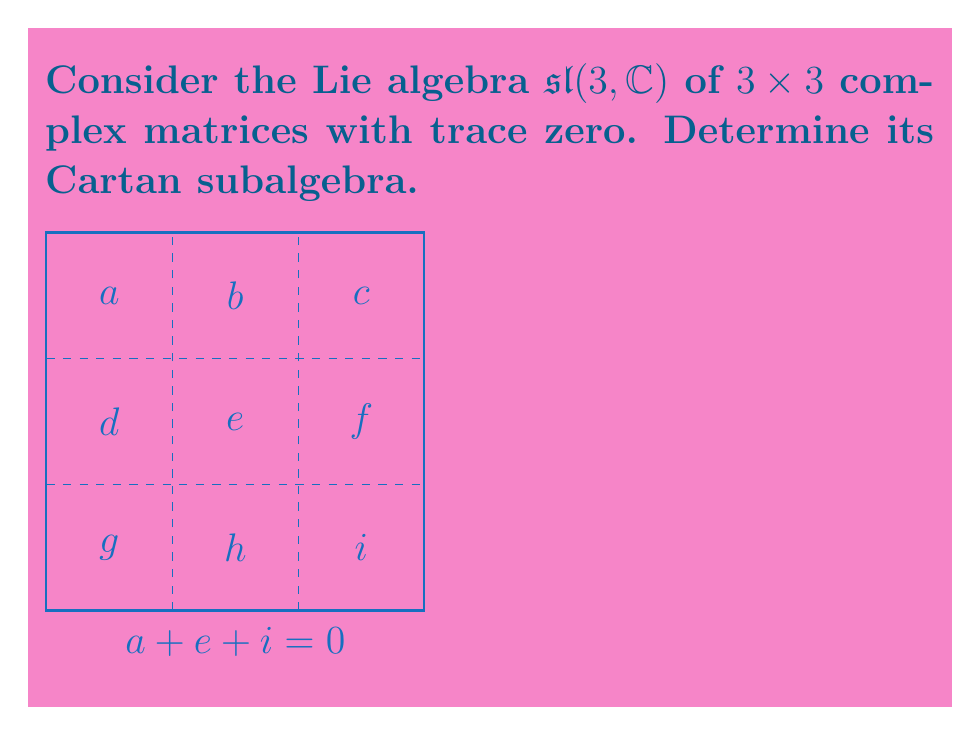Can you answer this question? To determine the Cartan subalgebra of $\mathfrak{sl}(3, \mathbb{C})$, we follow these steps:

1) Recall that a Cartan subalgebra is a maximal abelian subalgebra consisting of semisimple elements.

2) In $\mathfrak{sl}(3, \mathbb{C})$, the diagonal matrices form a natural candidate for the Cartan subalgebra.

3) The general form of a diagonal matrix in $\mathfrak{sl}(3, \mathbb{C})$ is:

   $$\begin{pmatrix}
   a & 0 & 0 \\
   0 & b & 0 \\
   0 & 0 & c
   \end{pmatrix}$$

   where $a + b + c = 0$ (to ensure trace zero).

4) These matrices commute with each other, as all diagonal matrices commute.

5) They are semisimple, as diagonal matrices are always diagonalizable.

6) This subalgebra is maximal abelian. Any non-diagonal matrix added to this subalgebra would not commute with all elements.

7) The dimension of this subalgebra is 2, as we have two free parameters (a and b, with c determined by $c = -a-b$).

8) We can express a basis for this Cartan subalgebra as:

   $$H_1 = \begin{pmatrix}
   1 & 0 & 0 \\
   0 & -1 & 0 \\
   0 & 0 & 0
   \end{pmatrix}, \quad
   H_2 = \begin{pmatrix}
   1 & 0 & 0 \\
   0 & 0 & 0 \\
   0 & 0 & -1
   \end{pmatrix}$$

Therefore, the Cartan subalgebra of $\mathfrak{sl}(3, \mathbb{C})$ consists of all diagonal matrices with trace zero.
Answer: $\{\text{diag}(a,b,-(a+b)) : a,b \in \mathbb{C}\}$ 